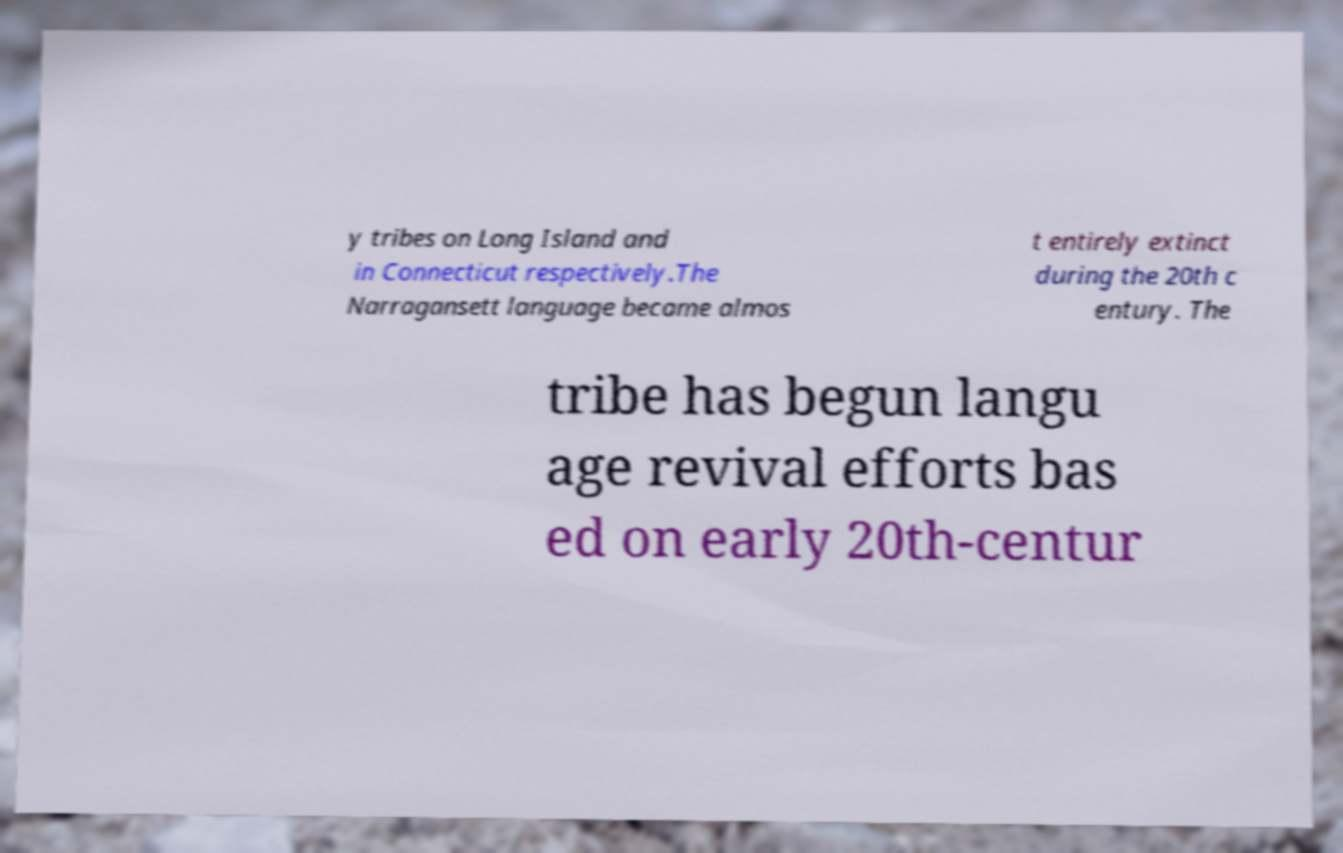Can you read and provide the text displayed in the image?This photo seems to have some interesting text. Can you extract and type it out for me? y tribes on Long Island and in Connecticut respectively.The Narragansett language became almos t entirely extinct during the 20th c entury. The tribe has begun langu age revival efforts bas ed on early 20th-centur 